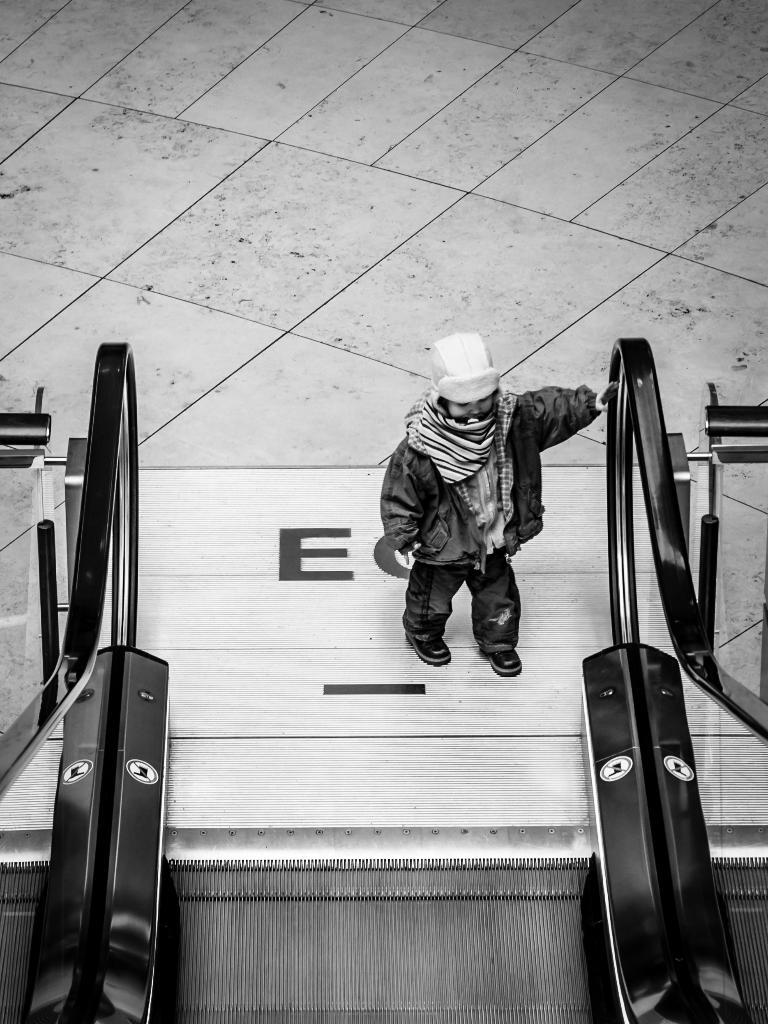What type of transportation device is present in the image? There is an escalator in the image. Can you describe the person in the image? The human in the image is standing and wearing a cap. What can be seen in the background of the image? There is a floor visible in the background of the image. What type of blood is visible on the escalator in the image? There is no blood visible on the escalator in the image. In which direction is the escalator moving in the image? The direction of the escalator cannot be determined from the image alone, as it is a static representation. 